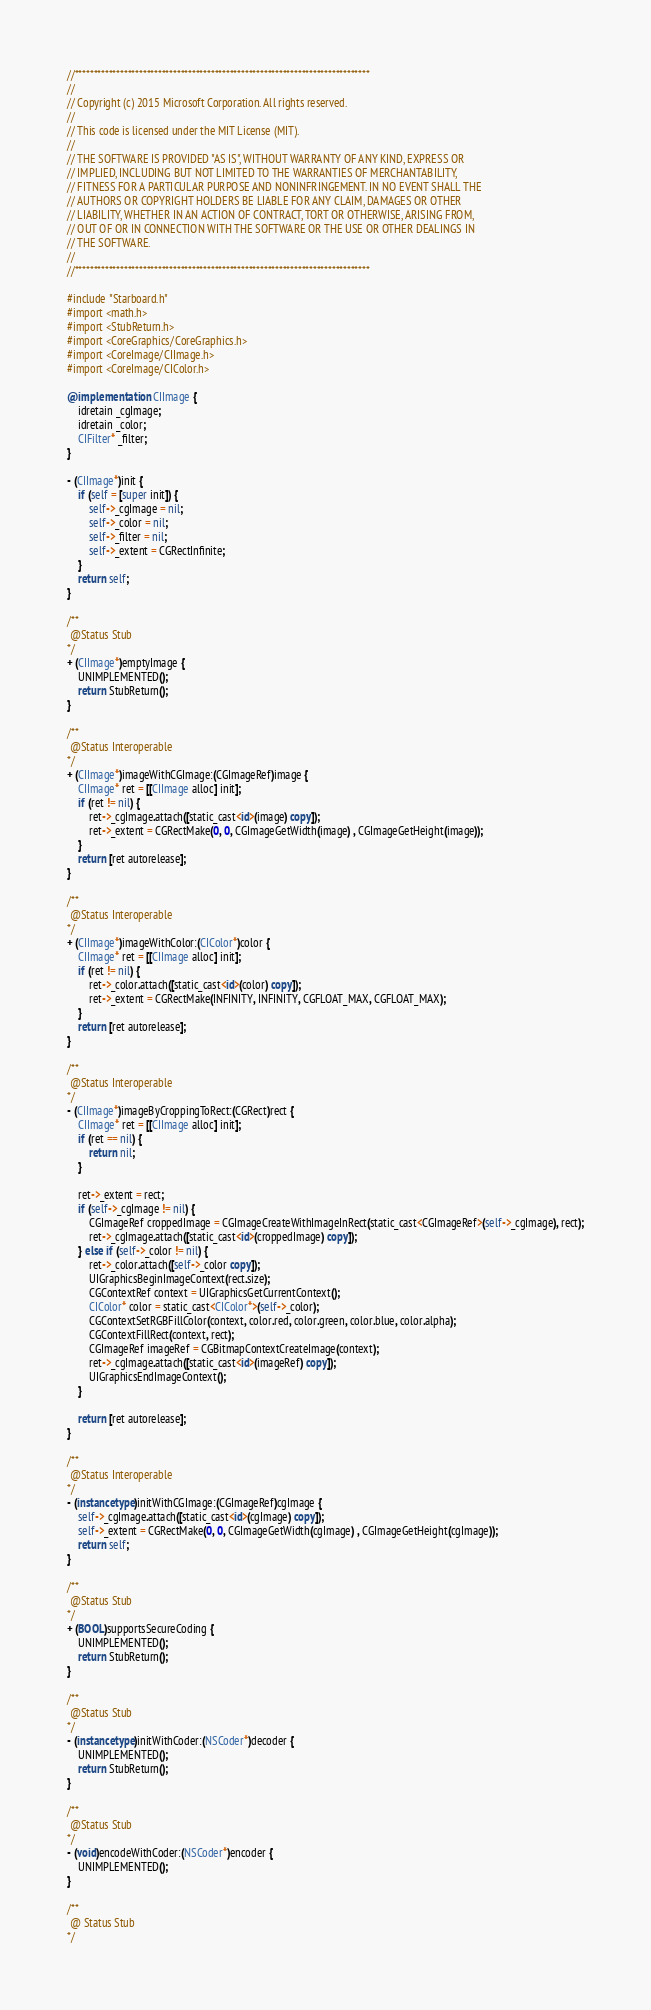Convert code to text. <code><loc_0><loc_0><loc_500><loc_500><_ObjectiveC_>//******************************************************************************
//
// Copyright (c) 2015 Microsoft Corporation. All rights reserved.
//
// This code is licensed under the MIT License (MIT).
//
// THE SOFTWARE IS PROVIDED "AS IS", WITHOUT WARRANTY OF ANY KIND, EXPRESS OR
// IMPLIED, INCLUDING BUT NOT LIMITED TO THE WARRANTIES OF MERCHANTABILITY,
// FITNESS FOR A PARTICULAR PURPOSE AND NONINFRINGEMENT. IN NO EVENT SHALL THE
// AUTHORS OR COPYRIGHT HOLDERS BE LIABLE FOR ANY CLAIM, DAMAGES OR OTHER
// LIABILITY, WHETHER IN AN ACTION OF CONTRACT, TORT OR OTHERWISE, ARISING FROM,
// OUT OF OR IN CONNECTION WITH THE SOFTWARE OR THE USE OR OTHER DEALINGS IN
// THE SOFTWARE.
//
//******************************************************************************

#include "Starboard.h"
#import <math.h>
#import <StubReturn.h>
#import <CoreGraphics/CoreGraphics.h>
#import <CoreImage/CIImage.h>
#import <CoreImage/CIColor.h>

@implementation CIImage {
    idretain _cgImage;
    idretain _color;
    CIFilter* _filter;
}

- (CIImage*)init {
    if (self = [super init]) {
        self->_cgImage = nil;
        self->_color = nil;
        self->_filter = nil;
        self->_extent = CGRectInfinite;
    }
    return self;
}

/**
 @Status Stub
*/
+ (CIImage*)emptyImage {
    UNIMPLEMENTED();
    return StubReturn();
}

/**
 @Status Interoperable
*/
+ (CIImage*)imageWithCGImage:(CGImageRef)image {
    CIImage* ret = [[CIImage alloc] init];
    if (ret != nil) {
        ret->_cgImage.attach([static_cast<id>(image) copy]);
        ret->_extent = CGRectMake(0, 0, CGImageGetWidth(image) , CGImageGetHeight(image));
    }
    return [ret autorelease];
}

/**
 @Status Interoperable
*/
+ (CIImage*)imageWithColor:(CIColor*)color {
    CIImage* ret = [[CIImage alloc] init];
    if (ret != nil) {
        ret->_color.attach([static_cast<id>(color) copy]);
        ret->_extent = CGRectMake(INFINITY, INFINITY, CGFLOAT_MAX, CGFLOAT_MAX);
    }
    return [ret autorelease];
}

/**
 @Status Interoperable
*/
- (CIImage*)imageByCroppingToRect:(CGRect)rect {
    CIImage* ret = [[CIImage alloc] init];
    if (ret == nil) {
        return nil;
    }

    ret->_extent = rect;
    if (self->_cgImage != nil) {
        CGImageRef croppedImage = CGImageCreateWithImageInRect(static_cast<CGImageRef>(self->_cgImage), rect);
        ret->_cgImage.attach([static_cast<id>(croppedImage) copy]);
    } else if (self->_color != nil) {
        ret->_color.attach([self->_color copy]);
        UIGraphicsBeginImageContext(rect.size);
        CGContextRef context = UIGraphicsGetCurrentContext();
        CIColor* color = static_cast<CIColor*>(self->_color);
        CGContextSetRGBFillColor(context, color.red, color.green, color.blue, color.alpha);
        CGContextFillRect(context, rect);
        CGImageRef imageRef = CGBitmapContextCreateImage(context);
        ret->_cgImage.attach([static_cast<id>(imageRef) copy]);
        UIGraphicsEndImageContext();
    } 

    return [ret autorelease];
}

/**
 @Status Interoperable
*/
- (instancetype)initWithCGImage:(CGImageRef)cgImage {
    self->_cgImage.attach([static_cast<id>(cgImage) copy]);
    self->_extent = CGRectMake(0, 0, CGImageGetWidth(cgImage) , CGImageGetHeight(cgImage));
    return self;
}

/**
 @Status Stub
*/
+ (BOOL)supportsSecureCoding {
    UNIMPLEMENTED();
    return StubReturn();
}

/**
 @Status Stub
*/
- (instancetype)initWithCoder:(NSCoder*)decoder {
    UNIMPLEMENTED();
    return StubReturn();
}

/**
 @Status Stub
*/
- (void)encodeWithCoder:(NSCoder*)encoder {
    UNIMPLEMENTED();
}

/**
 @ Status Stub
*/</code> 